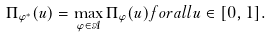Convert formula to latex. <formula><loc_0><loc_0><loc_500><loc_500>\Pi _ { \varphi ^ { * } } ( u ) = \max _ { \varphi \in \mathcal { A } } \Pi _ { \varphi } ( u ) f o r a l l u \in [ 0 , 1 ] .</formula> 